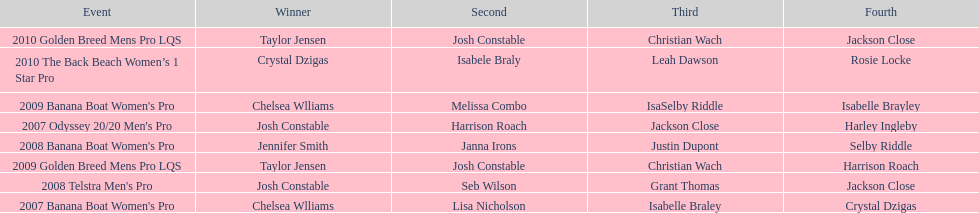Name each of the years that taylor jensen was winner. 2009, 2010. 